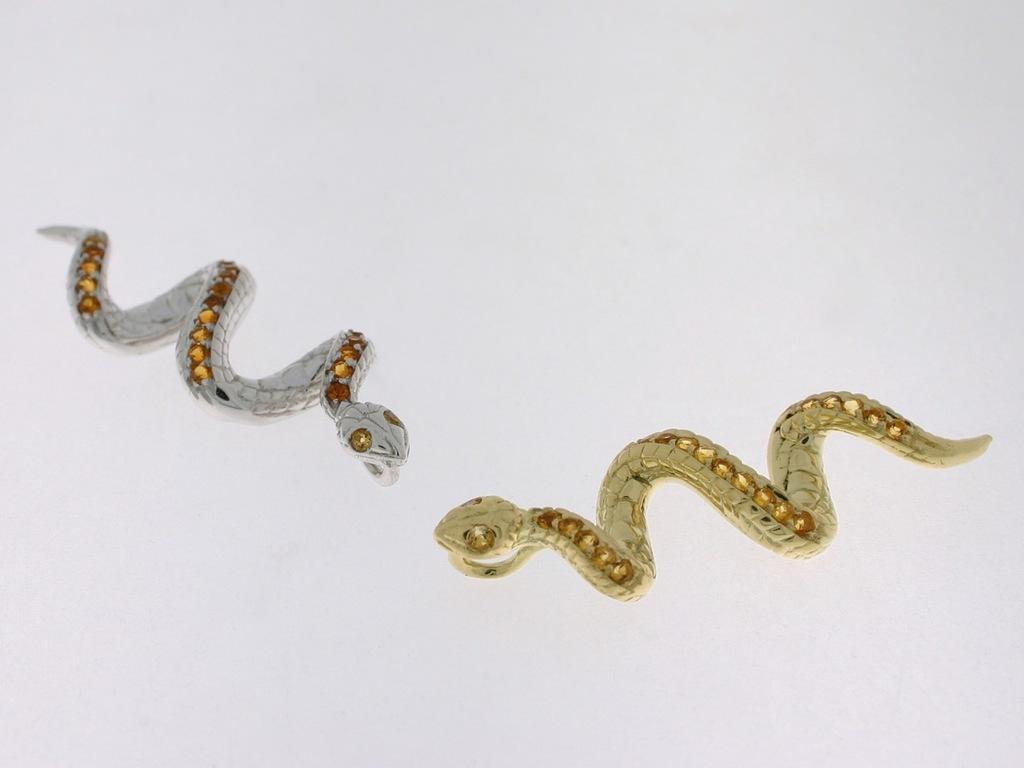In one or two sentences, can you explain what this image depicts? In this image we can see two snakes which looks like a artificial objects and we can see one is in gold color and the other one is silver color. 